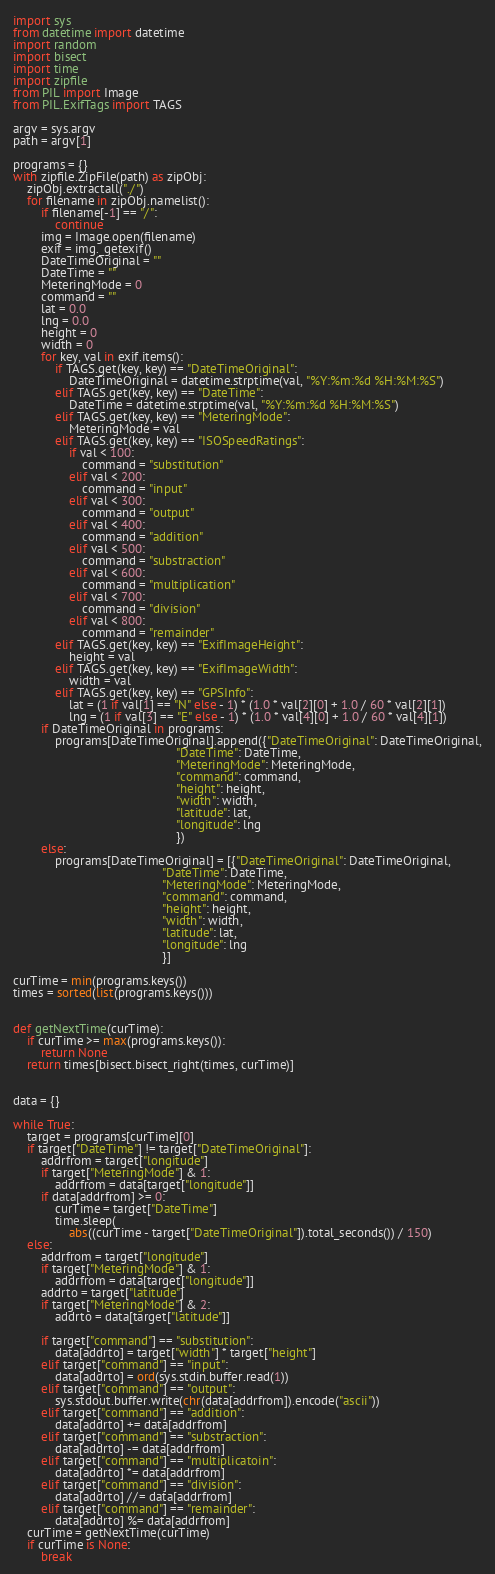<code> <loc_0><loc_0><loc_500><loc_500><_Python_>import sys
from datetime import datetime
import random
import bisect
import time
import zipfile
from PIL import Image
from PIL.ExifTags import TAGS

argv = sys.argv
path = argv[1]

programs = {}
with zipfile.ZipFile(path) as zipObj:
	zipObj.extractall("./")
	for filename in zipObj.namelist():
		if filename[-1] == "/":
			continue
		img = Image.open(filename)
		exif = img._getexif()
		DateTimeOriginal = ""
		DateTime = ""
		MeteringMode = 0
		command = ""
		lat = 0.0
		lng = 0.0
		height = 0
		width = 0
		for key, val in exif.items():
			if TAGS.get(key, key) == "DateTimeOriginal":
				DateTimeOriginal = datetime.strptime(val, "%Y:%m:%d %H:%M:%S")
			elif TAGS.get(key, key) == "DateTime":
				DateTime = datetime.strptime(val, "%Y:%m:%d %H:%M:%S")
			elif TAGS.get(key, key) == "MeteringMode":
				MeteringMode = val
			elif TAGS.get(key, key) == "ISOSpeedRatings":
				if val < 100:
					command = "substitution"
				elif val < 200:
					command = "input"
				elif val < 300:
					command = "output"
				elif val < 400:
					command = "addition"
				elif val < 500:
					command = "substraction"
				elif val < 600:
					command = "multiplication"
				elif val < 700:
					command = "division"
				elif val < 800:
					command = "remainder"
			elif TAGS.get(key, key) == "ExifImageHeight":
				height = val
			elif TAGS.get(key, key) == "ExifImageWidth":
				width = val
			elif TAGS.get(key, key) == "GPSInfo":
				lat = (1 if val[1] == "N" else - 1) * (1.0 * val[2][0] + 1.0 / 60 * val[2][1])
				lng = (1 if val[3] == "E" else - 1) * (1.0 * val[4][0] + 1.0 / 60 * val[4][1])
		if DateTimeOriginal in programs:
			programs[DateTimeOriginal].append({"DateTimeOriginal": DateTimeOriginal,
											   "DateTime": DateTime,
											   "MeteringMode": MeteringMode,
											   "command": command,
											   "height": height,
											   "width": width,
											   "latitude": lat,
											   "longitude": lng
											   })
		else:
			programs[DateTimeOriginal] = [{"DateTimeOriginal": DateTimeOriginal,
										   "DateTime": DateTime,
										   "MeteringMode": MeteringMode,
										   "command": command,
										   "height": height,
										   "width": width,
										   "latitude": lat,
										   "longitude": lng
										   }]

curTime = min(programs.keys())
times = sorted(list(programs.keys()))


def getNextTime(curTime):
	if curTime >= max(programs.keys()):
		return None
	return times[bisect.bisect_right(times, curTime)]


data = {}

while True:
	target = programs[curTime][0]
	if target["DateTime"] != target["DateTimeOriginal"]:
		addrfrom = target["longitude"]
		if target["MeteringMode"] & 1:
			addrfrom = data[target["longitude"]]
		if data[addrfrom] >= 0:
			curTime = target["DateTime"]
			time.sleep(
				abs((curTime - target["DateTimeOriginal"]).total_seconds()) / 150)
	else:
		addrfrom = target["longitude"]
		if target["MeteringMode"] & 1:
			addrfrom = data[target["longitude"]]
		addrto = target["latitude"]
		if target["MeteringMode"] & 2:
			addrto = data[target["latitude"]]

		if target["command"] == "substitution":
			data[addrto] = target["width"] * target["height"]
		elif target["command"] == "input":
			data[addrto] = ord(sys.stdin.buffer.read(1))
		elif target["command"] == "output":
			sys.stdout.buffer.write(chr(data[addrfrom]).encode("ascii"))
		elif target["command"] == "addition":
			data[addrto] += data[addrfrom]
		elif target["command"] == "substraction":
			data[addrto] -= data[addrfrom]
		elif target["command"] == "multiplicatoin":
			data[addrto] *= data[addrfrom]
		elif target["command"] == "division":
			data[addrto] //= data[addrfrom]
		elif target["command"] == "remainder":
			data[addrto] %= data[addrfrom]
	curTime = getNextTime(curTime)
	if curTime is None:
		break
</code> 